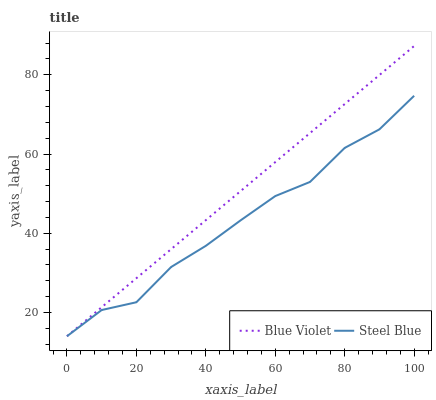Does Steel Blue have the minimum area under the curve?
Answer yes or no. Yes. Does Blue Violet have the maximum area under the curve?
Answer yes or no. Yes. Does Blue Violet have the minimum area under the curve?
Answer yes or no. No. Is Blue Violet the smoothest?
Answer yes or no. Yes. Is Steel Blue the roughest?
Answer yes or no. Yes. Is Blue Violet the roughest?
Answer yes or no. No. Does Steel Blue have the lowest value?
Answer yes or no. Yes. Does Blue Violet have the highest value?
Answer yes or no. Yes. Does Blue Violet intersect Steel Blue?
Answer yes or no. Yes. Is Blue Violet less than Steel Blue?
Answer yes or no. No. Is Blue Violet greater than Steel Blue?
Answer yes or no. No. 